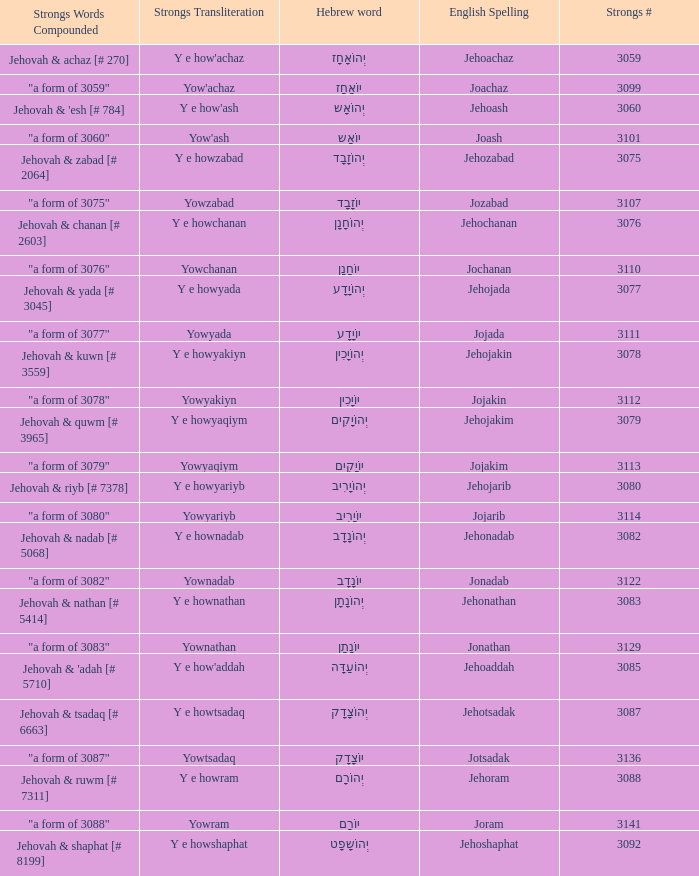What is the strong words compounded when the strongs transliteration is yowyariyb? "a form of 3080". 